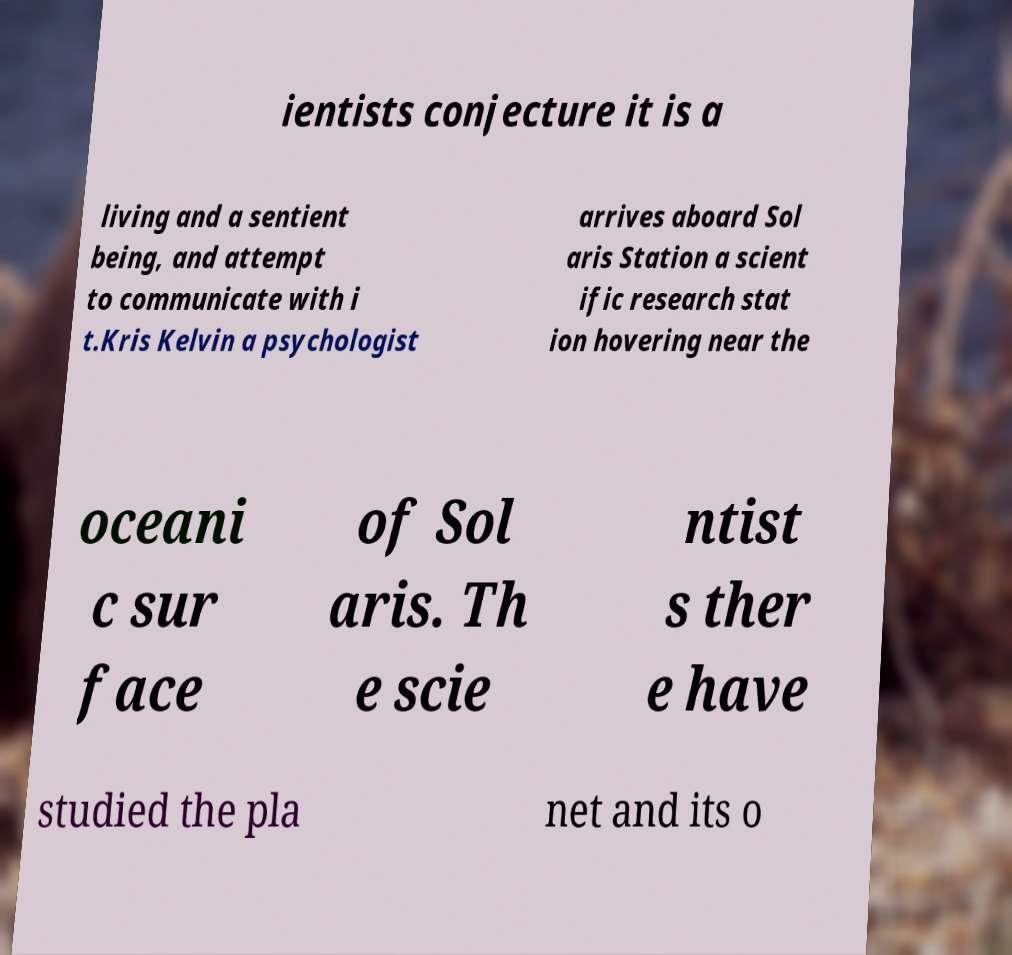Can you read and provide the text displayed in the image?This photo seems to have some interesting text. Can you extract and type it out for me? ientists conjecture it is a living and a sentient being, and attempt to communicate with i t.Kris Kelvin a psychologist arrives aboard Sol aris Station a scient ific research stat ion hovering near the oceani c sur face of Sol aris. Th e scie ntist s ther e have studied the pla net and its o 